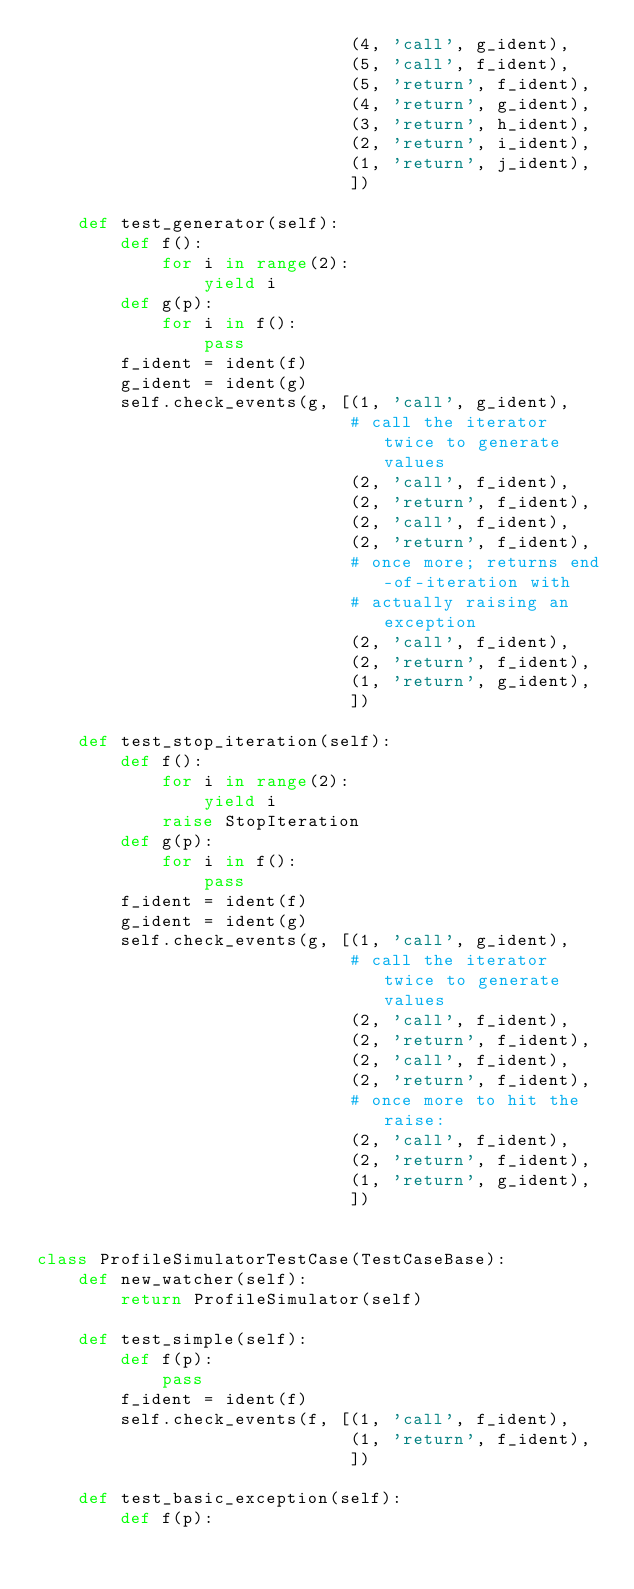Convert code to text. <code><loc_0><loc_0><loc_500><loc_500><_Python_>                              (4, 'call', g_ident),
                              (5, 'call', f_ident),
                              (5, 'return', f_ident),
                              (4, 'return', g_ident),
                              (3, 'return', h_ident),
                              (2, 'return', i_ident),
                              (1, 'return', j_ident),
                              ])

    def test_generator(self):
        def f():
            for i in range(2):
                yield i
        def g(p):
            for i in f():
                pass
        f_ident = ident(f)
        g_ident = ident(g)
        self.check_events(g, [(1, 'call', g_ident),
                              # call the iterator twice to generate values
                              (2, 'call', f_ident),
                              (2, 'return', f_ident),
                              (2, 'call', f_ident),
                              (2, 'return', f_ident),
                              # once more; returns end-of-iteration with
                              # actually raising an exception
                              (2, 'call', f_ident),
                              (2, 'return', f_ident),
                              (1, 'return', g_ident),
                              ])

    def test_stop_iteration(self):
        def f():
            for i in range(2):
                yield i
            raise StopIteration
        def g(p):
            for i in f():
                pass
        f_ident = ident(f)
        g_ident = ident(g)
        self.check_events(g, [(1, 'call', g_ident),
                              # call the iterator twice to generate values
                              (2, 'call', f_ident),
                              (2, 'return', f_ident),
                              (2, 'call', f_ident),
                              (2, 'return', f_ident),
                              # once more to hit the raise:
                              (2, 'call', f_ident),
                              (2, 'return', f_ident),
                              (1, 'return', g_ident),
                              ])


class ProfileSimulatorTestCase(TestCaseBase):
    def new_watcher(self):
        return ProfileSimulator(self)

    def test_simple(self):
        def f(p):
            pass
        f_ident = ident(f)
        self.check_events(f, [(1, 'call', f_ident),
                              (1, 'return', f_ident),
                              ])

    def test_basic_exception(self):
        def f(p):</code> 